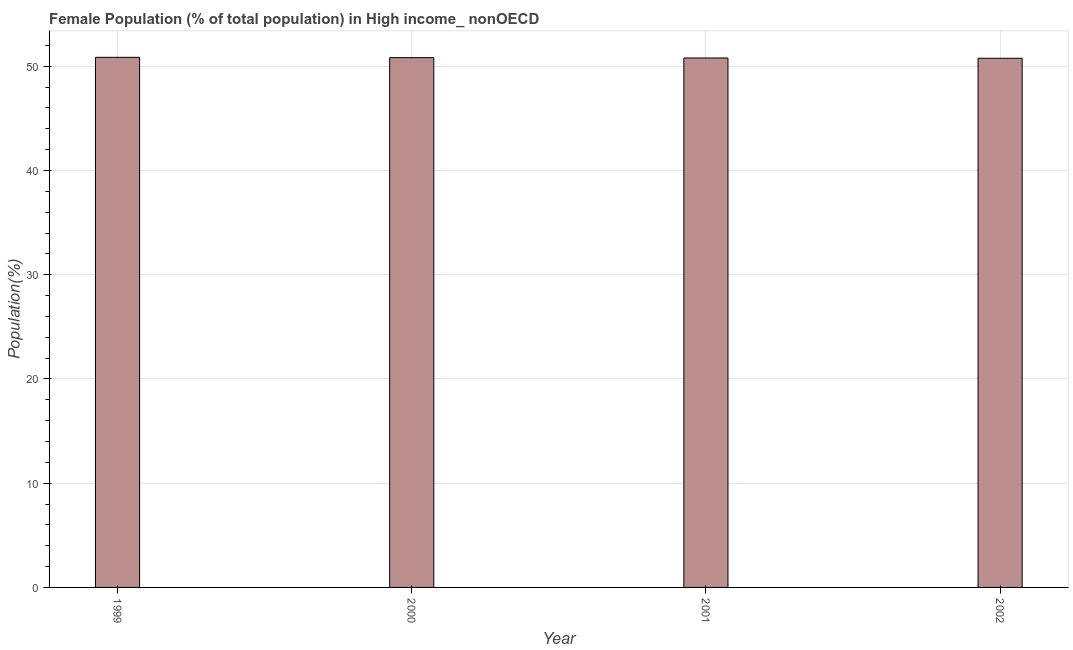Does the graph contain any zero values?
Make the answer very short. No. Does the graph contain grids?
Make the answer very short. Yes. What is the title of the graph?
Your response must be concise. Female Population (% of total population) in High income_ nonOECD. What is the label or title of the X-axis?
Give a very brief answer. Year. What is the label or title of the Y-axis?
Keep it short and to the point. Population(%). What is the female population in 2002?
Your answer should be compact. 50.77. Across all years, what is the maximum female population?
Ensure brevity in your answer.  50.86. Across all years, what is the minimum female population?
Your response must be concise. 50.77. In which year was the female population maximum?
Make the answer very short. 1999. What is the sum of the female population?
Provide a succinct answer. 203.26. What is the difference between the female population in 1999 and 2002?
Your response must be concise. 0.09. What is the average female population per year?
Offer a terse response. 50.81. What is the median female population?
Your answer should be compact. 50.81. What is the ratio of the female population in 2000 to that in 2002?
Your answer should be compact. 1. Is the difference between the female population in 2000 and 2001 greater than the difference between any two years?
Offer a terse response. No. What is the difference between the highest and the second highest female population?
Provide a succinct answer. 0.03. What is the difference between the highest and the lowest female population?
Ensure brevity in your answer.  0.09. How many bars are there?
Offer a very short reply. 4. Are all the bars in the graph horizontal?
Ensure brevity in your answer.  No. How many years are there in the graph?
Keep it short and to the point. 4. What is the Population(%) in 1999?
Keep it short and to the point. 50.86. What is the Population(%) of 2000?
Keep it short and to the point. 50.83. What is the Population(%) in 2001?
Your answer should be very brief. 50.8. What is the Population(%) in 2002?
Offer a very short reply. 50.77. What is the difference between the Population(%) in 1999 and 2000?
Your answer should be very brief. 0.03. What is the difference between the Population(%) in 1999 and 2001?
Offer a terse response. 0.06. What is the difference between the Population(%) in 1999 and 2002?
Provide a succinct answer. 0.09. What is the difference between the Population(%) in 2000 and 2001?
Your response must be concise. 0.03. What is the difference between the Population(%) in 2000 and 2002?
Offer a terse response. 0.06. What is the difference between the Population(%) in 2001 and 2002?
Your response must be concise. 0.03. What is the ratio of the Population(%) in 1999 to that in 2002?
Make the answer very short. 1. What is the ratio of the Population(%) in 2000 to that in 2001?
Offer a very short reply. 1. What is the ratio of the Population(%) in 2000 to that in 2002?
Provide a succinct answer. 1. What is the ratio of the Population(%) in 2001 to that in 2002?
Provide a succinct answer. 1. 